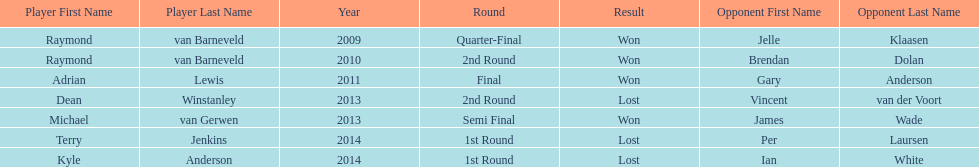Would you mind parsing the complete table? {'header': ['Player First Name', 'Player Last Name', 'Year', 'Round', 'Result', 'Opponent First Name', 'Opponent Last Name'], 'rows': [['Raymond', 'van Barneveld', '2009', 'Quarter-Final', 'Won', 'Jelle', 'Klaasen'], ['Raymond', 'van Barneveld', '2010', '2nd Round', 'Won', 'Brendan', 'Dolan'], ['Adrian', 'Lewis', '2011', 'Final', 'Won', 'Gary', 'Anderson'], ['Dean', 'Winstanley', '2013', '2nd Round', 'Lost', 'Vincent', 'van der Voort'], ['Michael', 'van Gerwen', '2013', 'Semi Final', 'Won', 'James', 'Wade'], ['Terry', 'Jenkins', '2014', '1st Round', 'Lost', 'Per', 'Laursen'], ['Kyle', 'Anderson', '2014', '1st Round', 'Lost', 'Ian', 'White']]} Is dean winstanley listed above or below kyle anderson? Above. 